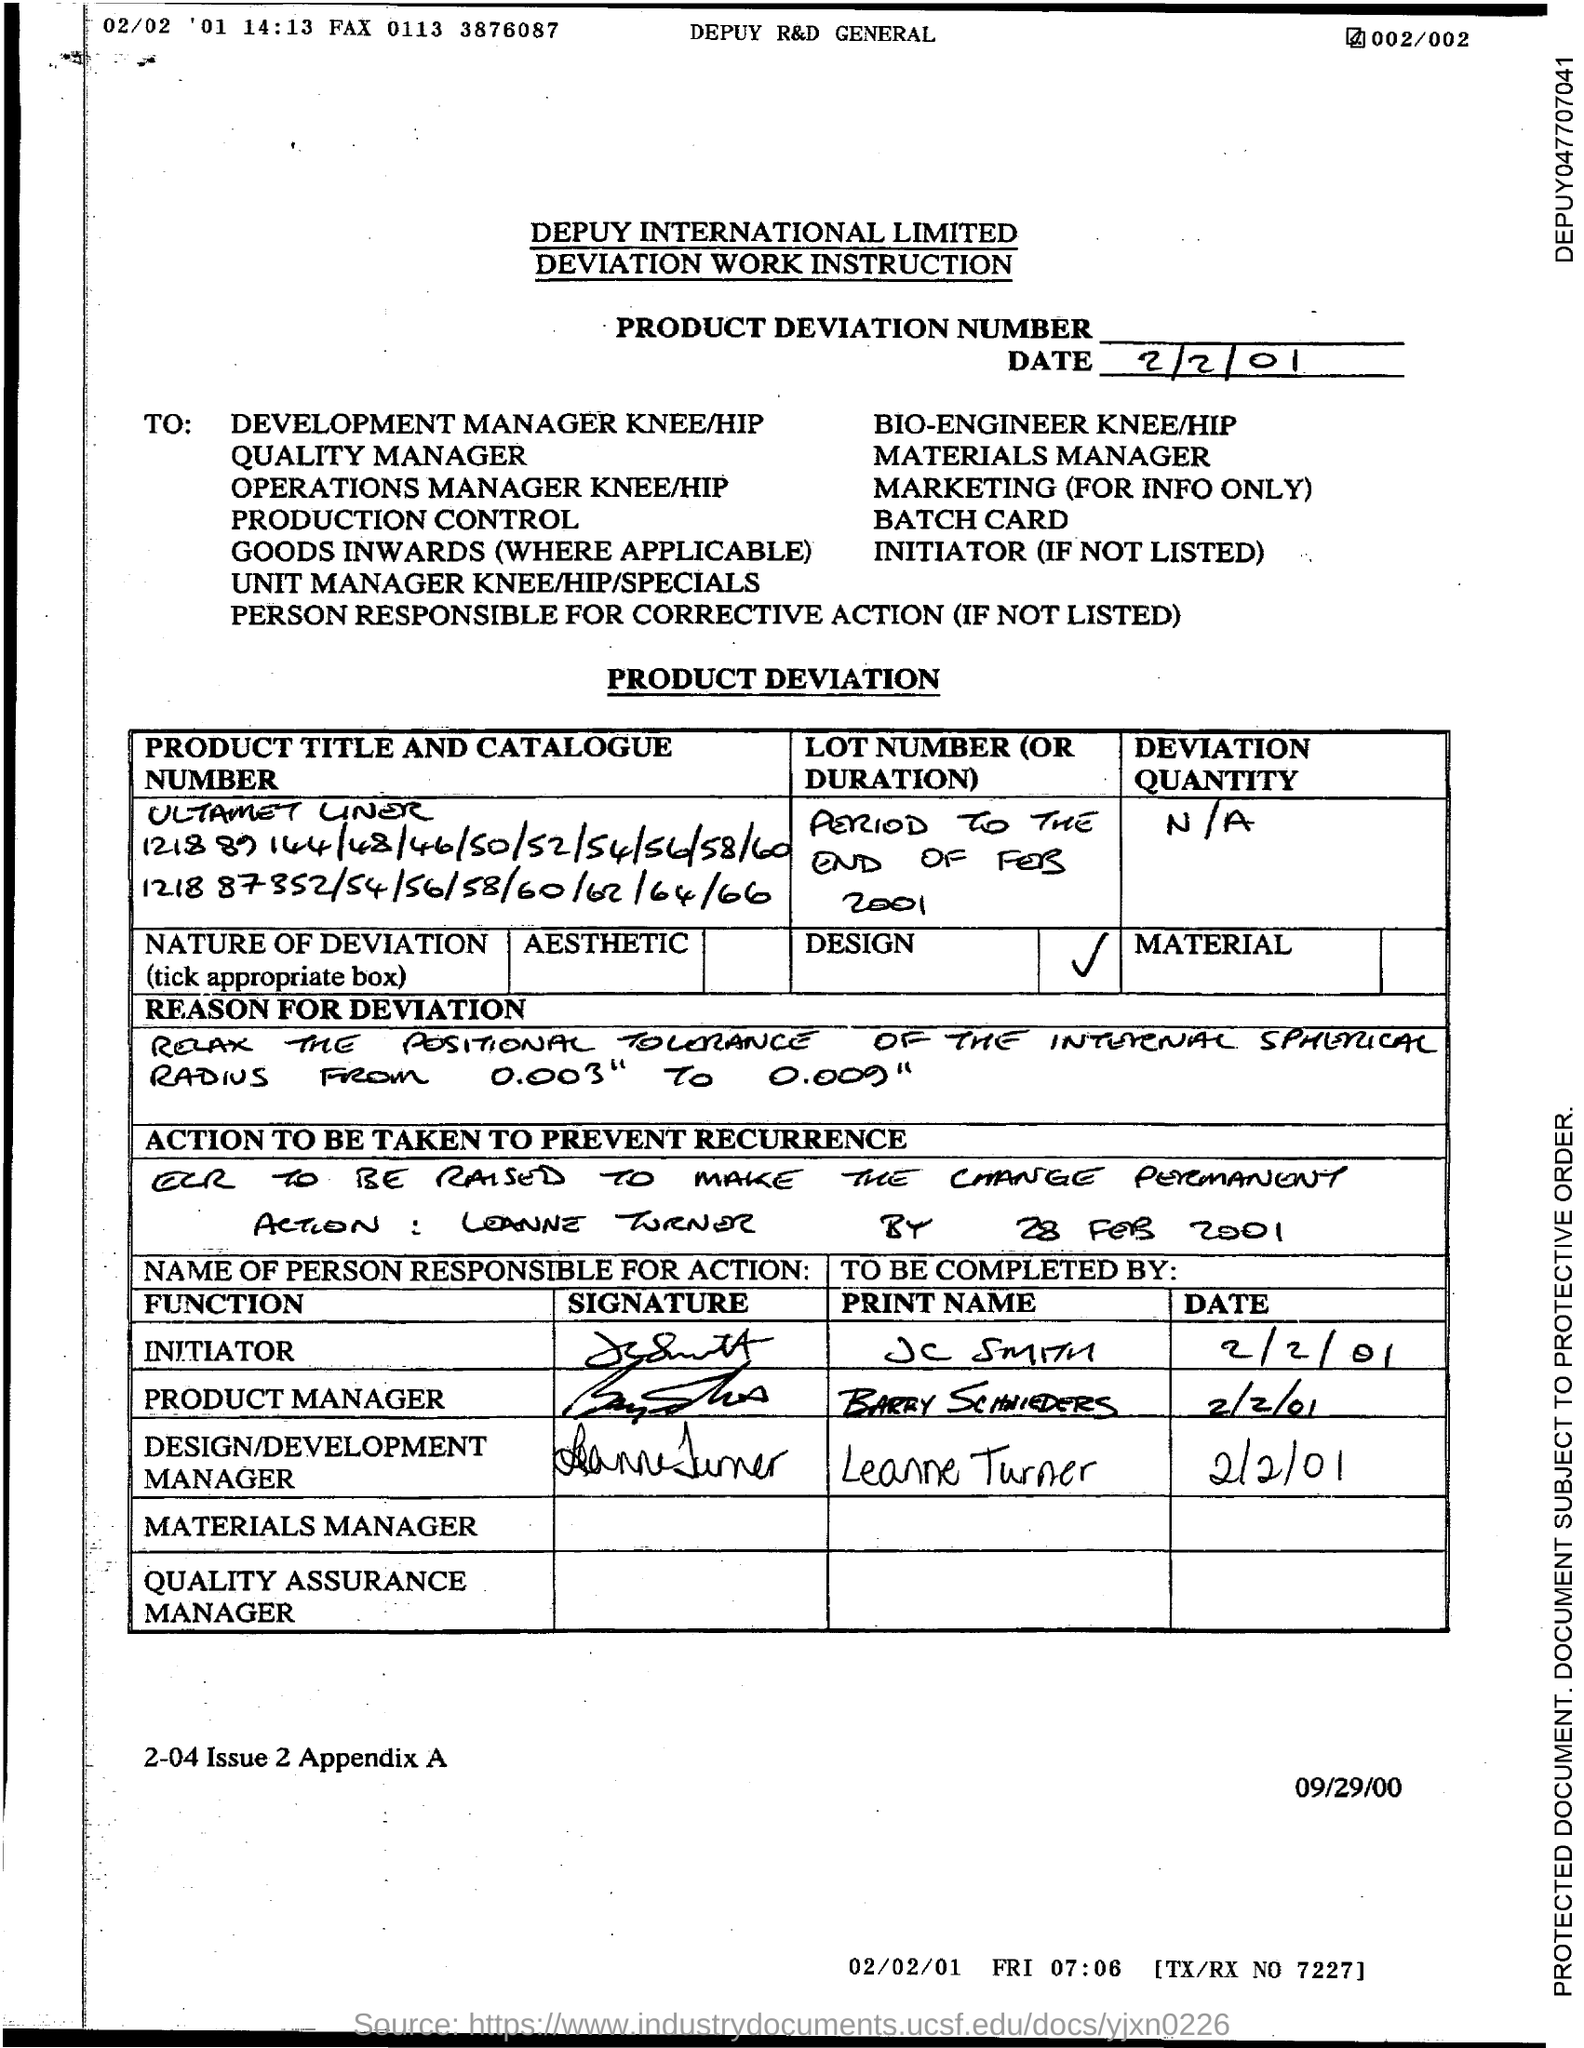What is the name of design/development manager?
Provide a succinct answer. Leanne Turner. 